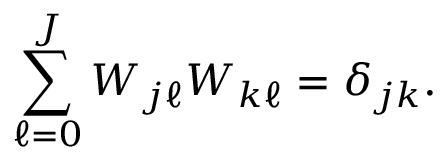<formula> <loc_0><loc_0><loc_500><loc_500>\sum _ { \ell = 0 } ^ { J } W _ { j \ell } W _ { k \ell } = \delta _ { j k } .</formula> 